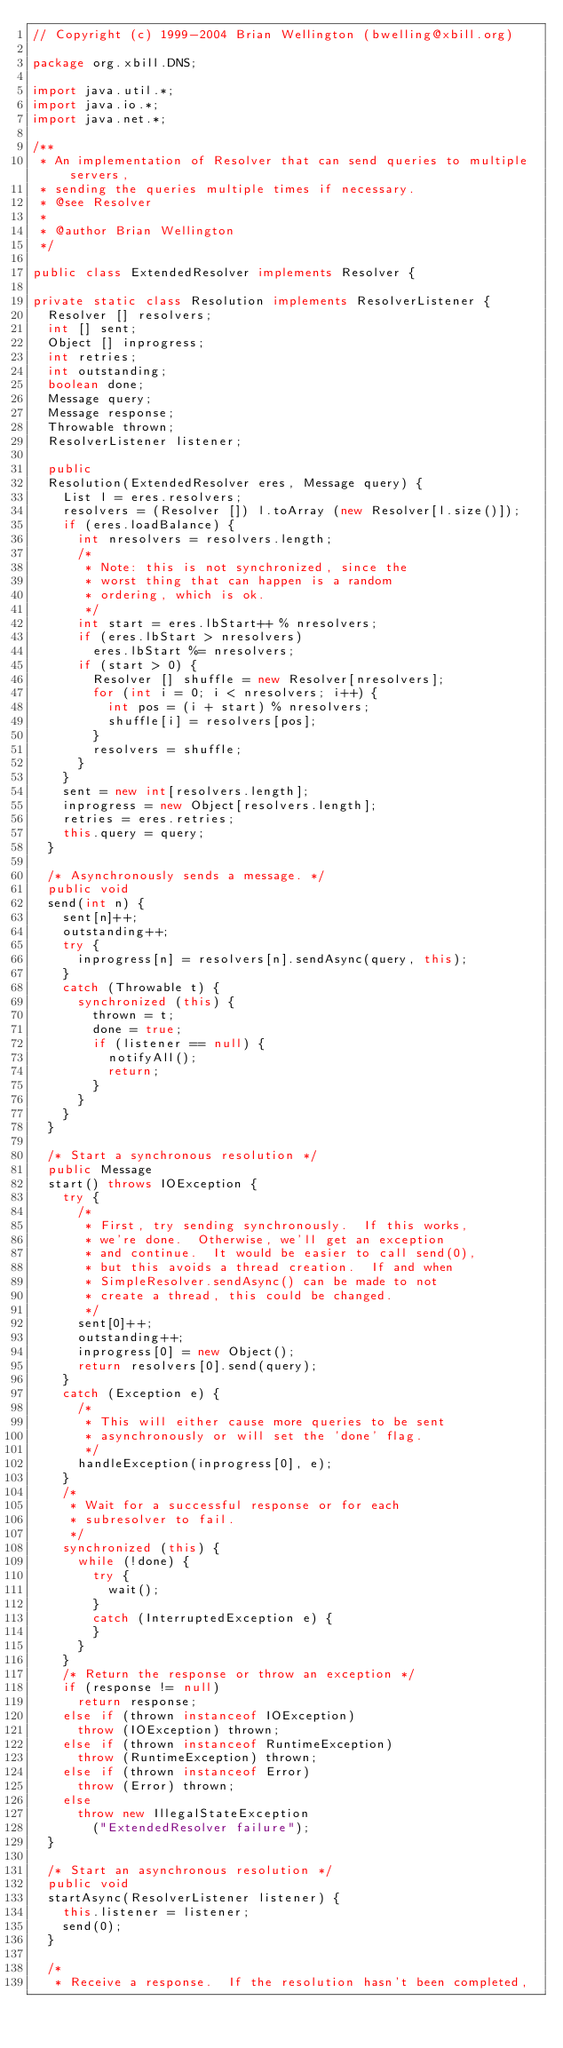<code> <loc_0><loc_0><loc_500><loc_500><_Java_>// Copyright (c) 1999-2004 Brian Wellington (bwelling@xbill.org)

package org.xbill.DNS;

import java.util.*;
import java.io.*;
import java.net.*;

/**
 * An implementation of Resolver that can send queries to multiple servers,
 * sending the queries multiple times if necessary.
 * @see Resolver
 *
 * @author Brian Wellington
 */

public class ExtendedResolver implements Resolver {

private static class Resolution implements ResolverListener {
	Resolver [] resolvers;
	int [] sent;
	Object [] inprogress;
	int retries;
	int outstanding;
	boolean done;
	Message query;
	Message response;
	Throwable thrown;
	ResolverListener listener;

	public
	Resolution(ExtendedResolver eres, Message query) {
		List l = eres.resolvers;
		resolvers = (Resolver []) l.toArray (new Resolver[l.size()]);
		if (eres.loadBalance) {
			int nresolvers = resolvers.length;
			/*
			 * Note: this is not synchronized, since the
			 * worst thing that can happen is a random
			 * ordering, which is ok.
			 */
			int start = eres.lbStart++ % nresolvers;
			if (eres.lbStart > nresolvers)
				eres.lbStart %= nresolvers;
			if (start > 0) {
				Resolver [] shuffle = new Resolver[nresolvers];
				for (int i = 0; i < nresolvers; i++) {
					int pos = (i + start) % nresolvers;
					shuffle[i] = resolvers[pos];
				}
				resolvers = shuffle;
			}
		}
		sent = new int[resolvers.length];
		inprogress = new Object[resolvers.length];
		retries = eres.retries;
		this.query = query;
	}

	/* Asynchronously sends a message. */
	public void
	send(int n) {
		sent[n]++;
		outstanding++;
		try {
			inprogress[n] = resolvers[n].sendAsync(query, this);
		}
		catch (Throwable t) {
			synchronized (this) {
				thrown = t;
				done = true;
				if (listener == null) {
					notifyAll();
					return;
				}
			}
		}
	}

	/* Start a synchronous resolution */
	public Message
	start() throws IOException {
		try {
			/*
			 * First, try sending synchronously.  If this works,
			 * we're done.  Otherwise, we'll get an exception
			 * and continue.  It would be easier to call send(0),
			 * but this avoids a thread creation.  If and when
			 * SimpleResolver.sendAsync() can be made to not
			 * create a thread, this could be changed.
			 */
			sent[0]++;
			outstanding++;
			inprogress[0] = new Object();
			return resolvers[0].send(query);
		}
		catch (Exception e) {
			/*
			 * This will either cause more queries to be sent
			 * asynchronously or will set the 'done' flag.
			 */
			handleException(inprogress[0], e);
		}
		/*
		 * Wait for a successful response or for each
		 * subresolver to fail.
		 */
		synchronized (this) {
			while (!done) {
				try {
					wait();
				}
				catch (InterruptedException e) {
				}
			}
		}
		/* Return the response or throw an exception */
		if (response != null)
			return response;
		else if (thrown instanceof IOException)
			throw (IOException) thrown;
		else if (thrown instanceof RuntimeException)
			throw (RuntimeException) thrown;
		else if (thrown instanceof Error)
			throw (Error) thrown;
		else
			throw new IllegalStateException
				("ExtendedResolver failure");
	}

	/* Start an asynchronous resolution */
	public void
	startAsync(ResolverListener listener) {
		this.listener = listener;
		send(0);
	}

	/*
	 * Receive a response.  If the resolution hasn't been completed,</code> 